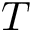<formula> <loc_0><loc_0><loc_500><loc_500>T</formula> 